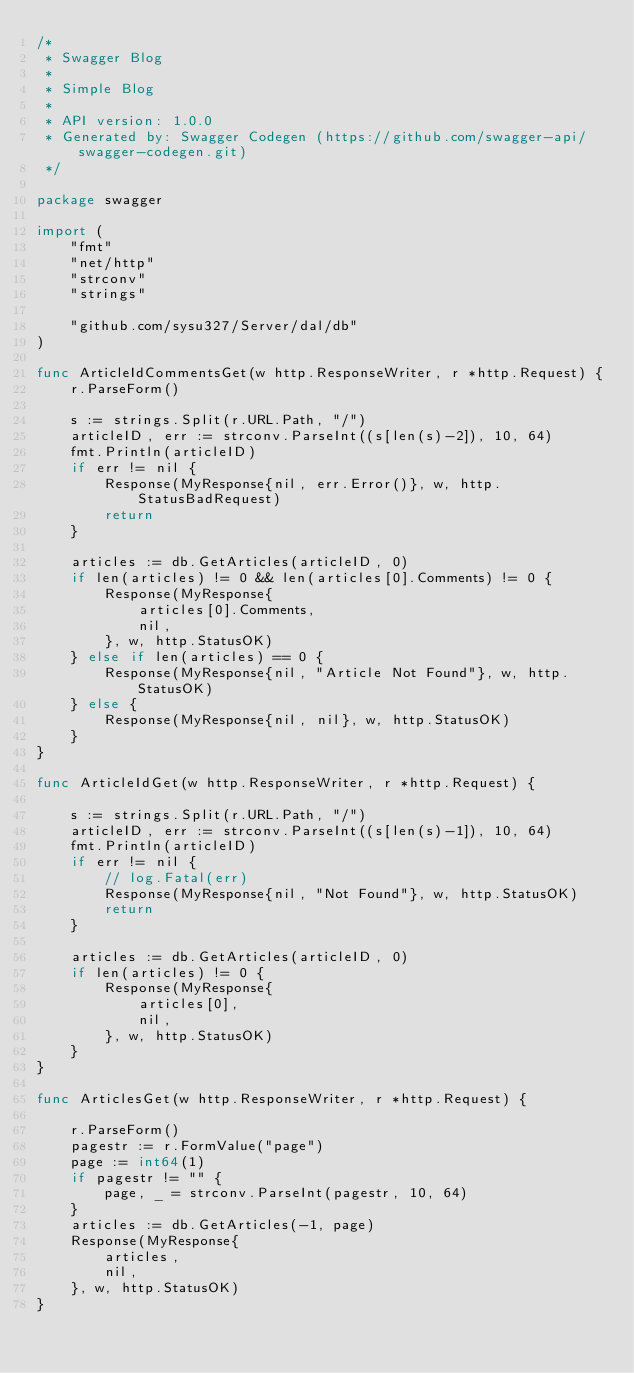<code> <loc_0><loc_0><loc_500><loc_500><_Go_>/*
 * Swagger Blog
 *
 * Simple Blog
 *
 * API version: 1.0.0
 * Generated by: Swagger Codegen (https://github.com/swagger-api/swagger-codegen.git)
 */

package swagger

import (
	"fmt"
	"net/http"
	"strconv"
	"strings"

	"github.com/sysu327/Server/dal/db"
)

func ArticleIdCommentsGet(w http.ResponseWriter, r *http.Request) {
	r.ParseForm()

	s := strings.Split(r.URL.Path, "/")
	articleID, err := strconv.ParseInt((s[len(s)-2]), 10, 64)
	fmt.Println(articleID)
	if err != nil {
		Response(MyResponse{nil, err.Error()}, w, http.StatusBadRequest)
		return
	}

	articles := db.GetArticles(articleID, 0)
	if len(articles) != 0 && len(articles[0].Comments) != 0 {
		Response(MyResponse{
			articles[0].Comments,
			nil,
		}, w, http.StatusOK)
	} else if len(articles) == 0 {
		Response(MyResponse{nil, "Article Not Found"}, w, http.StatusOK)
	} else {
		Response(MyResponse{nil, nil}, w, http.StatusOK)
	}
}

func ArticleIdGet(w http.ResponseWriter, r *http.Request) {

	s := strings.Split(r.URL.Path, "/")
	articleID, err := strconv.ParseInt((s[len(s)-1]), 10, 64)
	fmt.Println(articleID)
	if err != nil {
		// log.Fatal(err)
		Response(MyResponse{nil, "Not Found"}, w, http.StatusOK)
		return
	}

	articles := db.GetArticles(articleID, 0)
	if len(articles) != 0 {
		Response(MyResponse{
			articles[0],
			nil,
		}, w, http.StatusOK)
	}
}

func ArticlesGet(w http.ResponseWriter, r *http.Request) {

	r.ParseForm()
	pagestr := r.FormValue("page")
	page := int64(1)
	if pagestr != "" {
		page, _ = strconv.ParseInt(pagestr, 10, 64)
	}
	articles := db.GetArticles(-1, page)
	Response(MyResponse{
		articles,
		nil,
	}, w, http.StatusOK)
}
</code> 